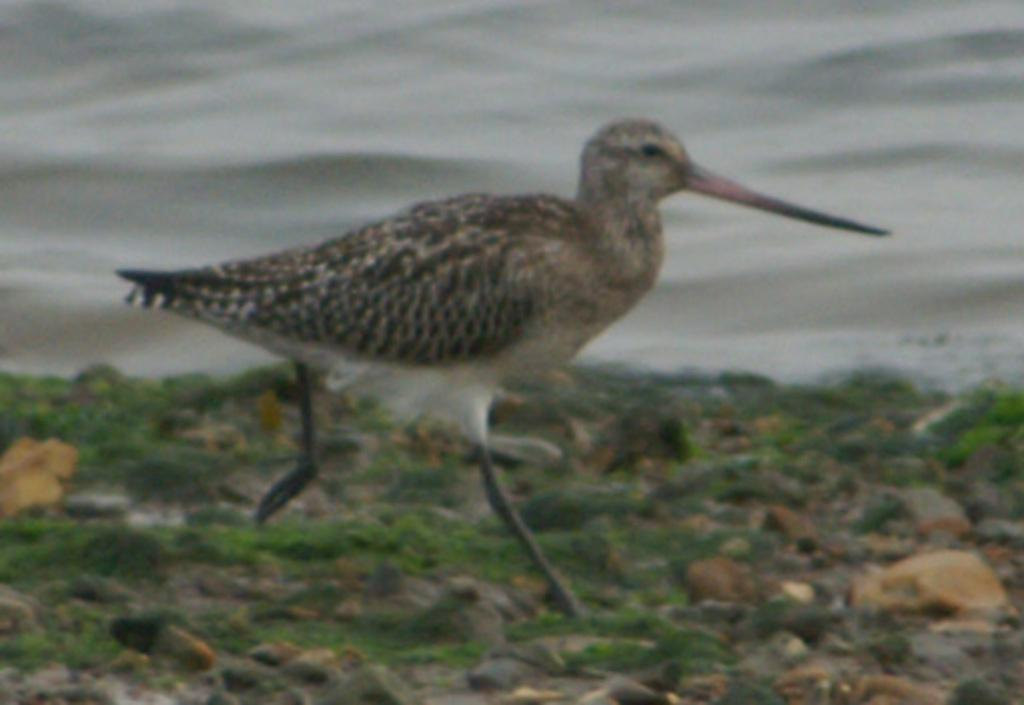What is the main subject in the center of the image? There is a bird in the center of the image. What type of terrain is visible at the bottom of the image? There are stones and grass at the bottom of the image. What can be seen at the top of the image? There is water visible at the top of the image. What songs are the ducks singing in the image? There are no ducks present in the image, so there is no singing or songs to be heard. 